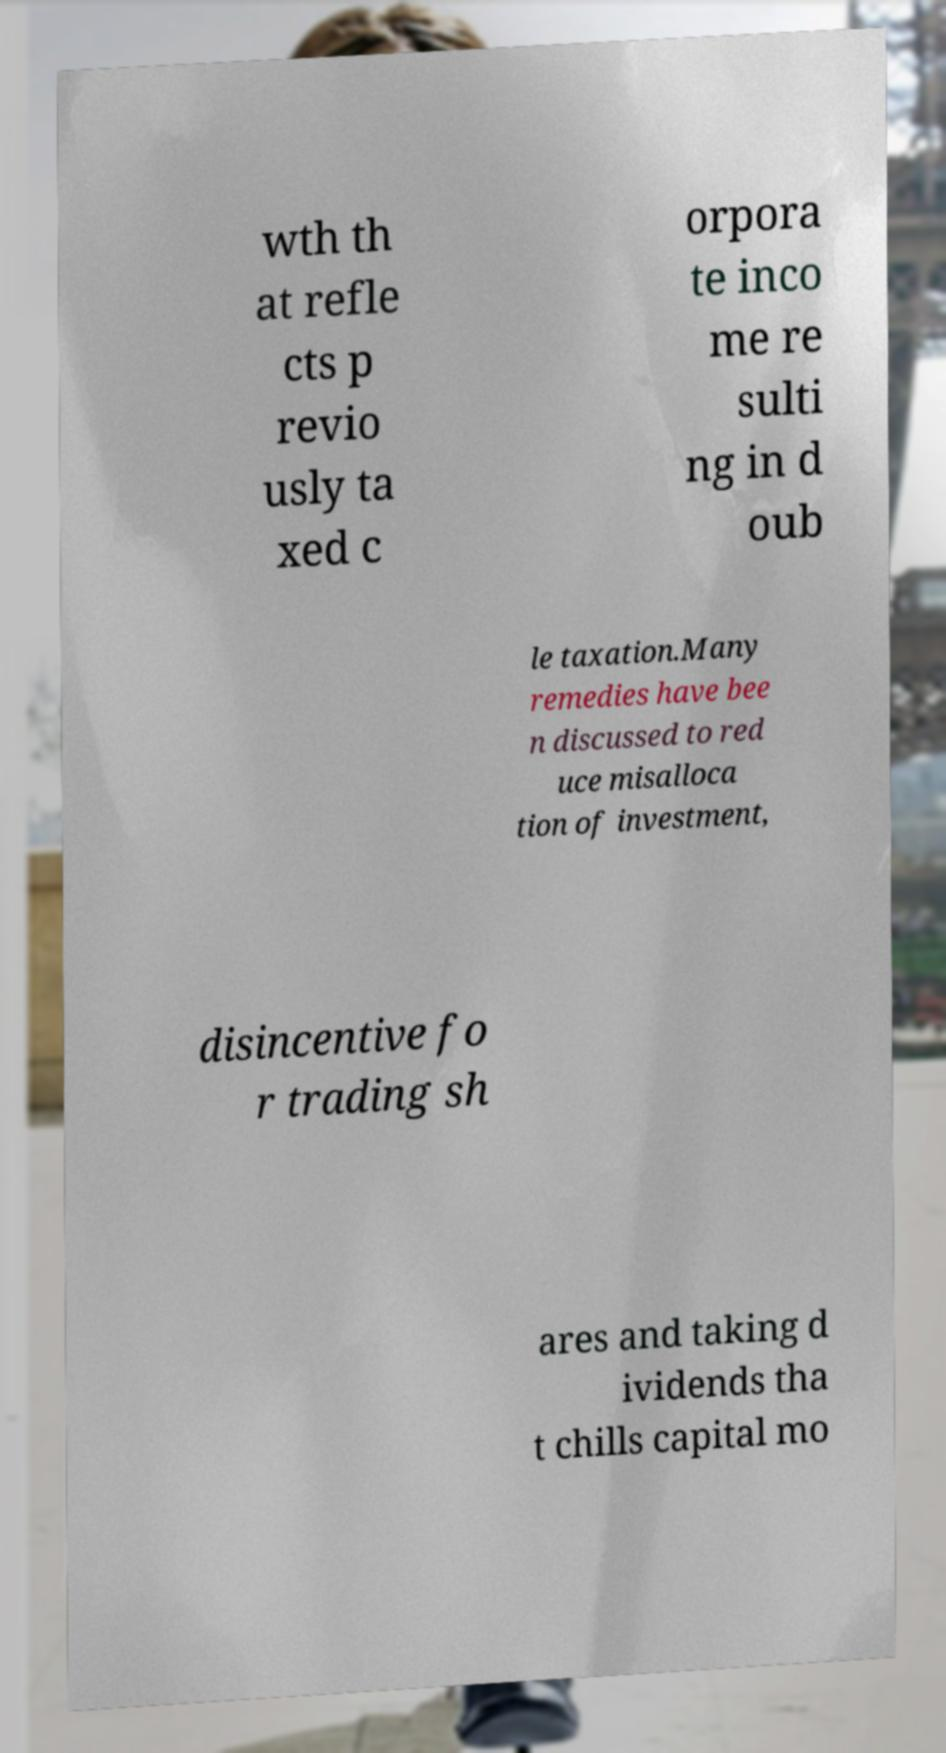I need the written content from this picture converted into text. Can you do that? wth th at refle cts p revio usly ta xed c orpora te inco me re sulti ng in d oub le taxation.Many remedies have bee n discussed to red uce misalloca tion of investment, disincentive fo r trading sh ares and taking d ividends tha t chills capital mo 